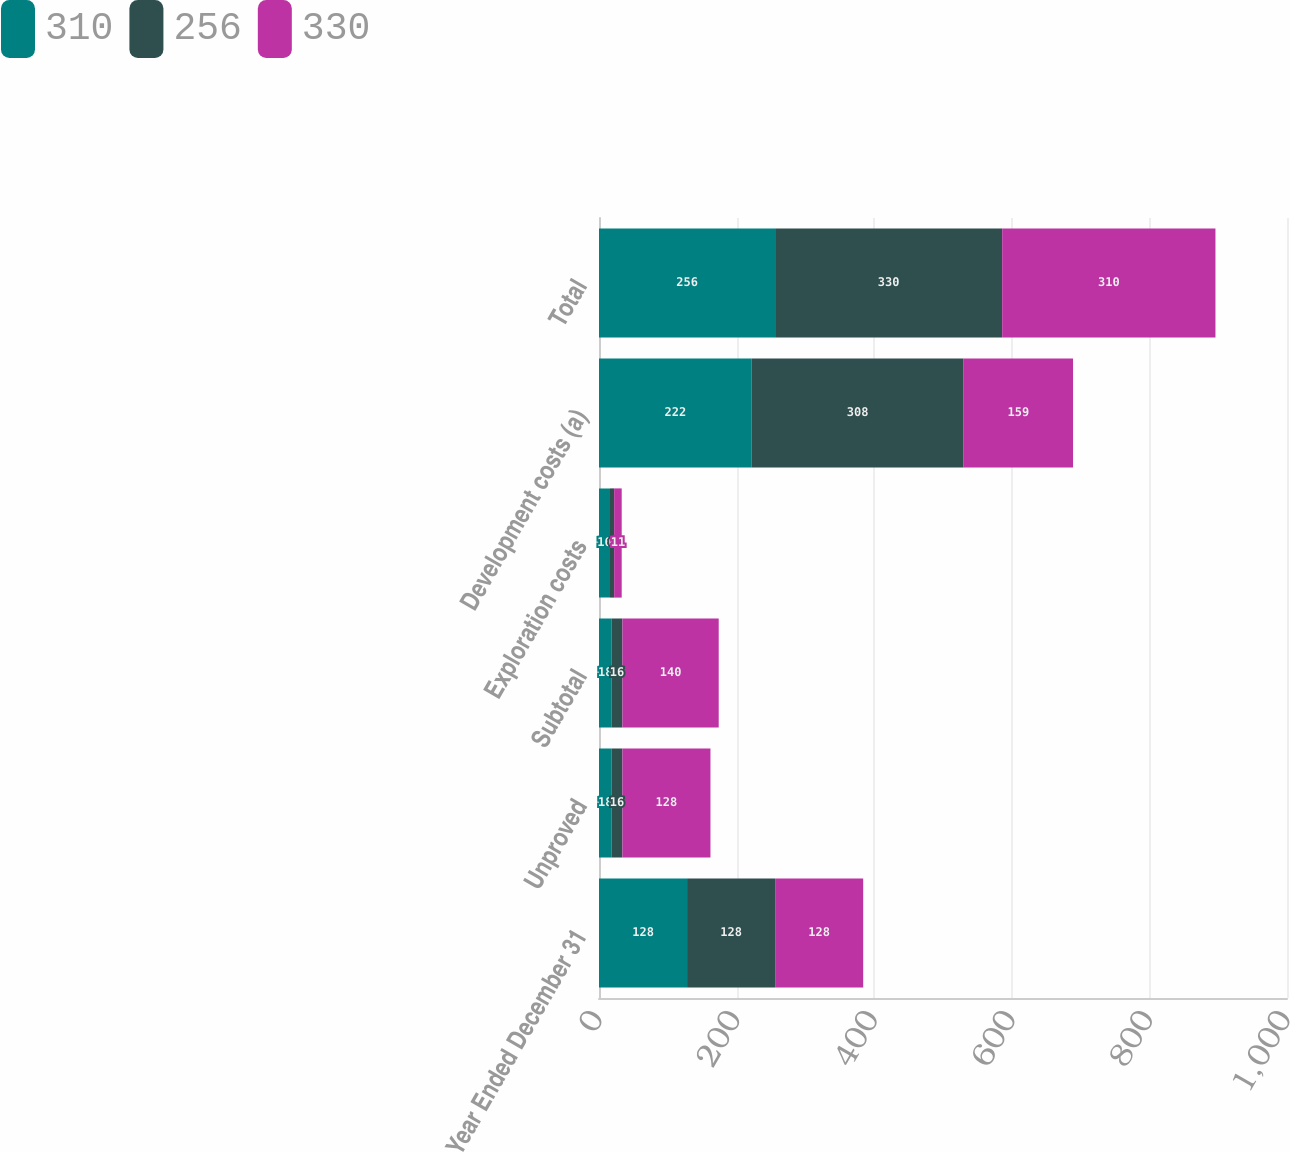Convert chart. <chart><loc_0><loc_0><loc_500><loc_500><stacked_bar_chart><ecel><fcel>Year Ended December 31<fcel>Unproved<fcel>Subtotal<fcel>Exploration costs<fcel>Development costs (a)<fcel>Total<nl><fcel>310<fcel>128<fcel>18<fcel>18<fcel>16<fcel>222<fcel>256<nl><fcel>256<fcel>128<fcel>16<fcel>16<fcel>6<fcel>308<fcel>330<nl><fcel>330<fcel>128<fcel>128<fcel>140<fcel>11<fcel>159<fcel>310<nl></chart> 